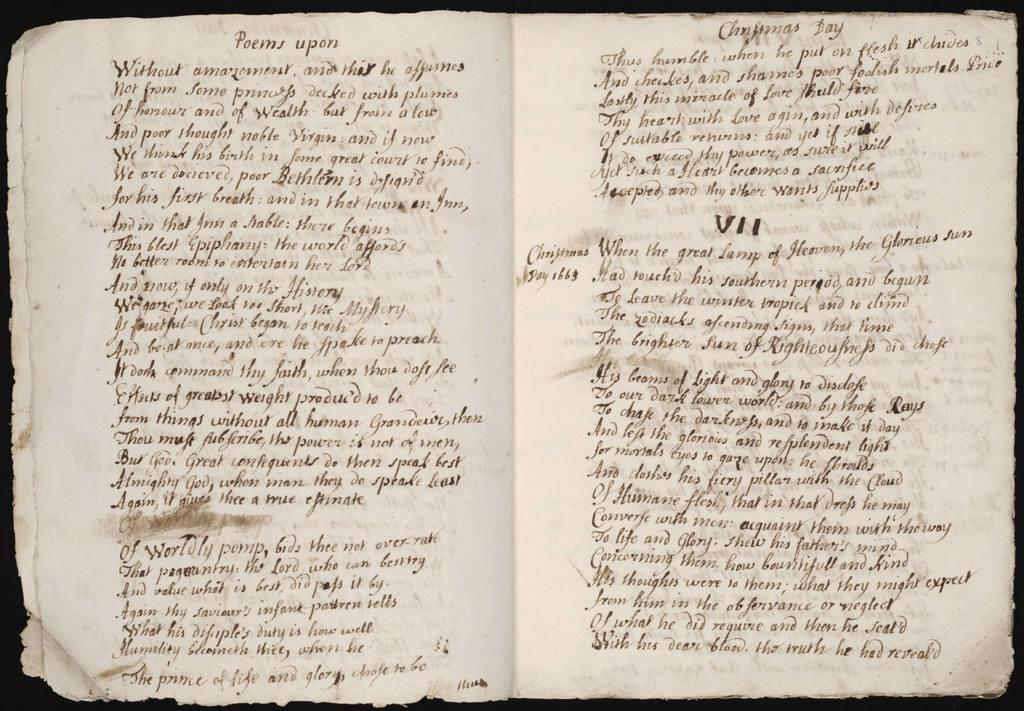<image>
Present a compact description of the photo's key features. An antique book is opened to section VII. 